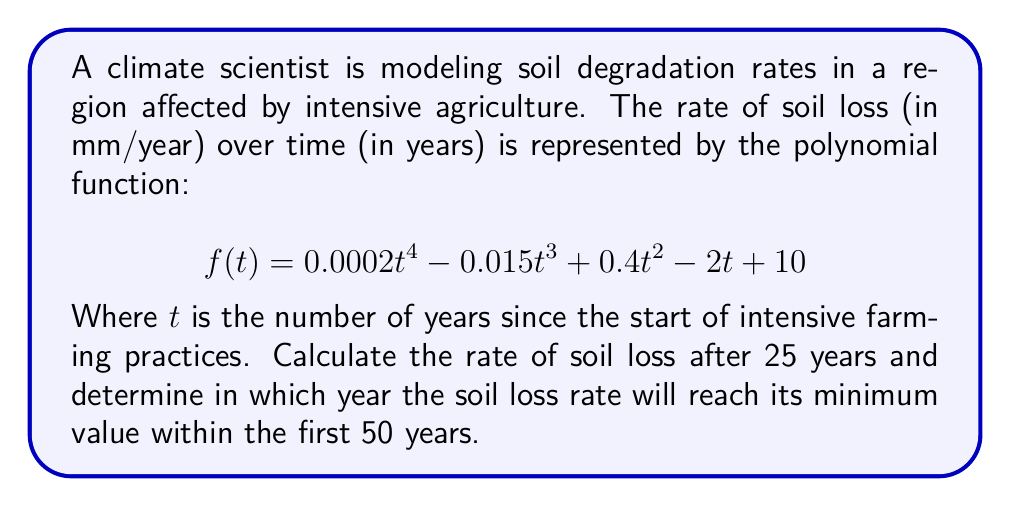Teach me how to tackle this problem. 1. To find the rate of soil loss after 25 years, we simply need to evaluate $f(25)$:

   $$\begin{aligned}
   f(25) &= 0.0002(25)^4 - 0.015(25)^3 + 0.4(25)^2 - 2(25) + 10 \\
   &= 0.0002(390625) - 0.015(15625) + 0.4(625) - 2(25) + 10 \\
   &= 78.125 - 234.375 + 250 - 50 + 10 \\
   &= 53.75 \text{ mm/year}
   \end{aligned}$$

2. To find the year when the soil loss rate reaches its minimum, we need to find the global minimum of $f(t)$ within the interval $[0, 50]$. This can be done by finding the roots of the derivative $f'(t)$ and evaluating $f(t)$ at these points and the endpoints.

3. The derivative of $f(t)$ is:
   $$f'(t) = 0.0008t^3 - 0.045t^2 + 0.8t - 2$$

4. Setting $f'(t) = 0$ and solving for $t$ gives us the critical points. This is a cubic equation and can be solved numerically. The roots are approximately:
   $t \approx 2.69, 15.63, 37.93$

5. Evaluating $f(t)$ at these points and the endpoints:
   $f(0) = 10$
   $f(2.69) \approx 5.28$
   $f(15.63) \approx 5.06$
   $f(37.93) \approx 89.94$
   $f(50) \approx 385.00$

6. The minimum value occurs at $t \approx 15.63$ years, which rounds to 16 years.
Answer: 53.75 mm/year after 25 years; minimum at 16 years 